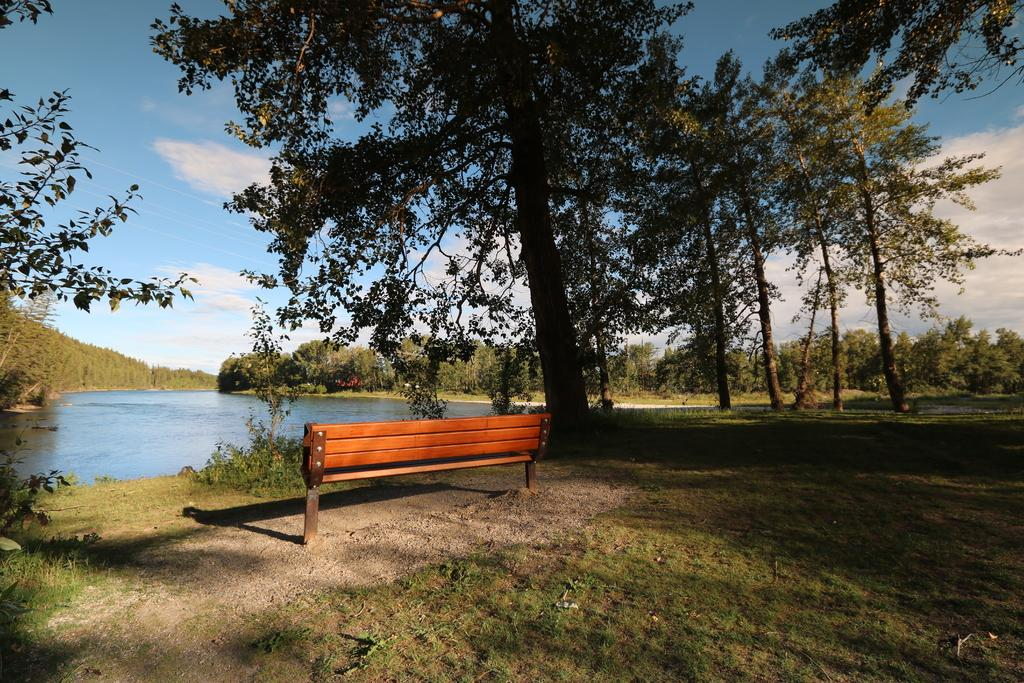What type of vegetation can be seen in the image? There are trees and plants visible in the image. What natural element is present in the image? There is water visible in the image. What type of ground cover is present in the image? There is grass in the image. What type of seating is present in the image? There is a bench in the image. What is visible in the background of the image? The sky is visible in the background of the image. How many rings are visible on the trees in the image? There are no rings visible on the trees in the image. What type of bird is depicted interacting with the geese in the image? There are no geese or birds depicted in the image. 